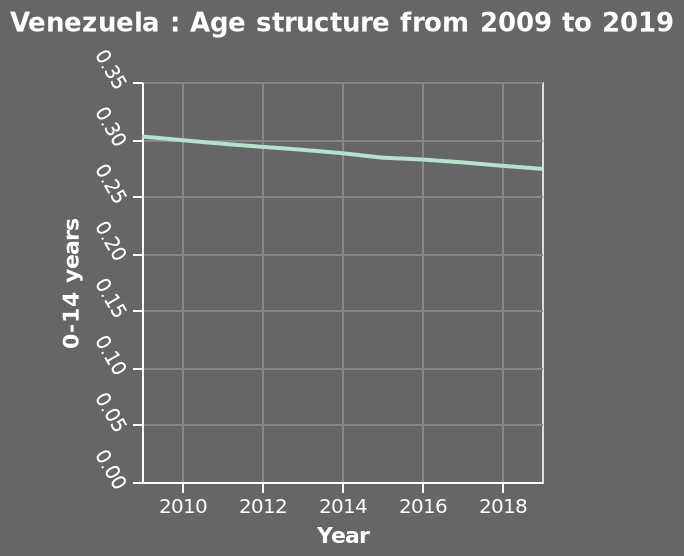<image>
In which year did the age structure for those aged 0-14 years in Venezuela reach its peak value?  The age structure for those aged 0-14 years in Venezuela reached its peak value in 2009. please describe the details of the chart This line chart is titled Venezuela : Age structure from 2009 to 2019. The x-axis measures Year while the y-axis plots 0-14 years. What was the change in the age structure for those aged 0-14 years in Venezuela from 2009 to 2019? The age structure for those aged 0-14 years in Venezuela decreased from just over 0.3 in 2009 to around 0.27 in 2019. Offer a thorough analysis of the image. The age structure of those aged 0 - 14 years in Venezuela peaked at just over 0.3 in 2009. The age structure steadily decreased to around 0.27 in 2019. 